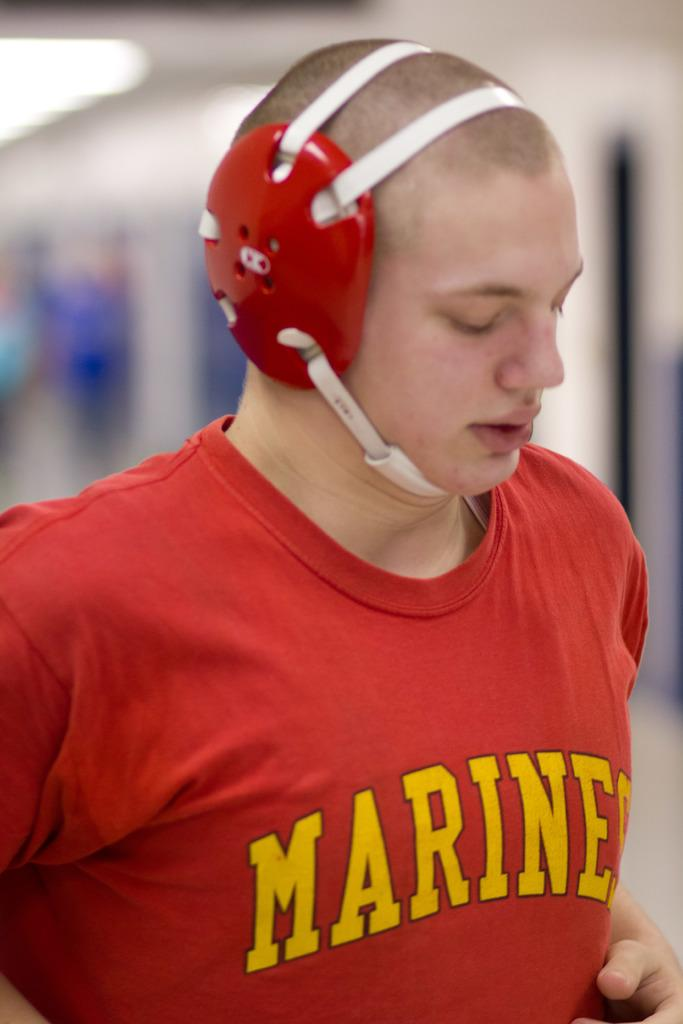What can be seen in the image? There is a person in the image. What is the person wearing? The person is wearing a T-shirt with text on it. Can you describe the background of the image? The background of the image is blurred. What type of cast can be seen on the person's leg in the image? There is no cast visible on the person's leg in the image. How many chickens are present in the image? There are no chickens present in the image. 